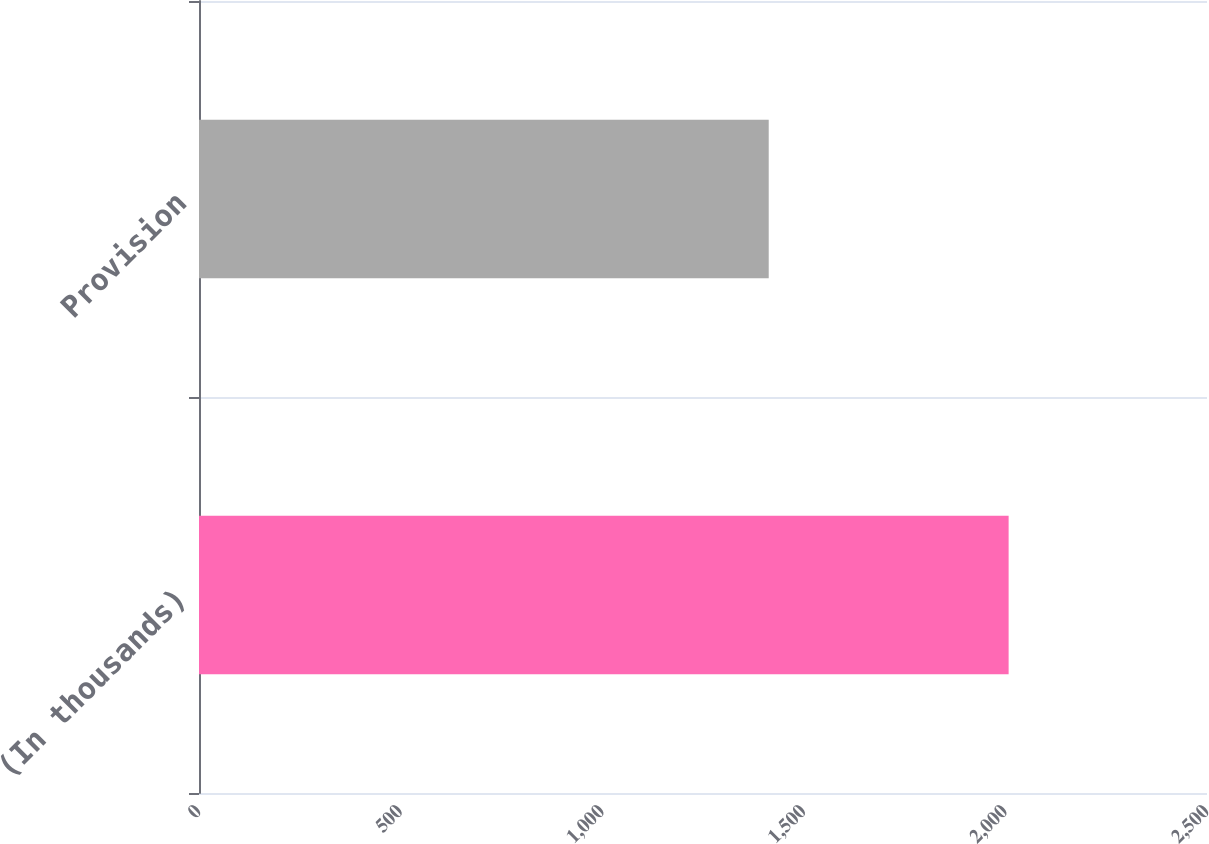Convert chart to OTSL. <chart><loc_0><loc_0><loc_500><loc_500><bar_chart><fcel>(In thousands)<fcel>Provision<nl><fcel>2008<fcel>1413<nl></chart> 